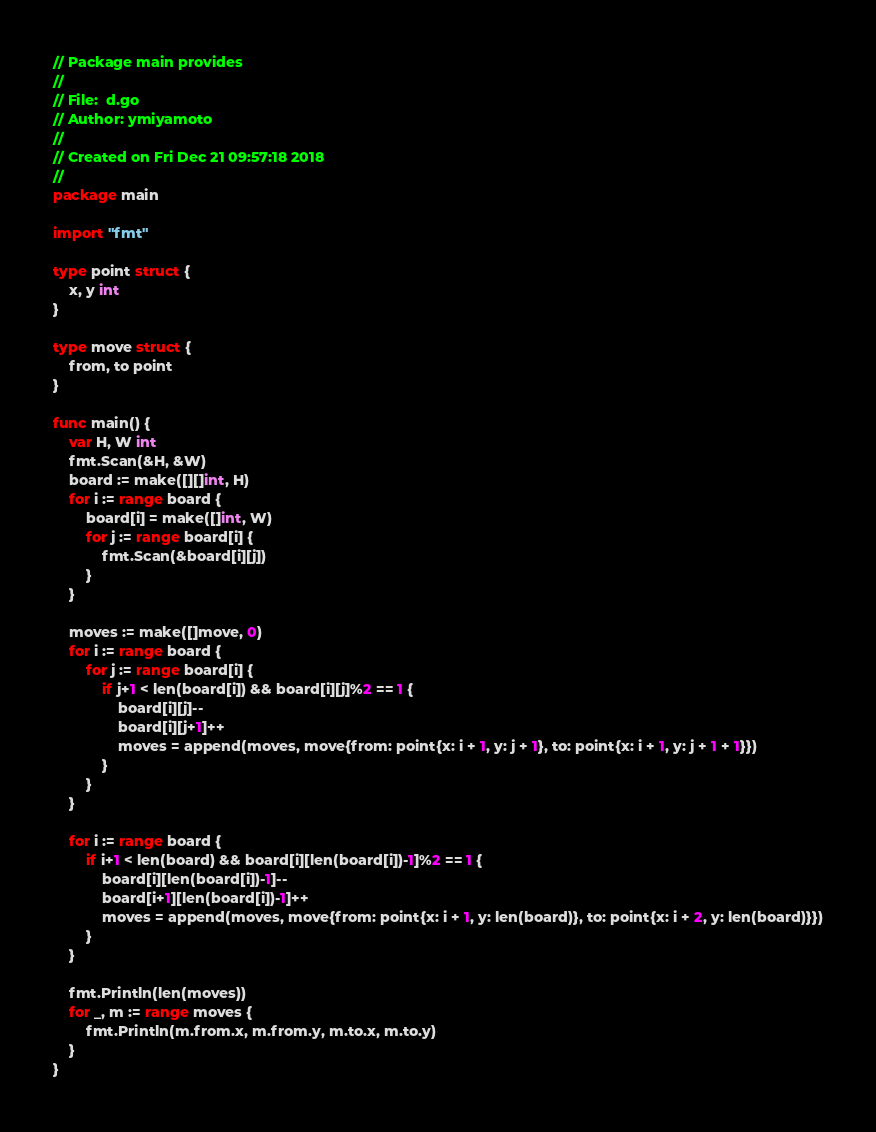<code> <loc_0><loc_0><loc_500><loc_500><_Go_>// Package main provides
//
// File:  d.go
// Author: ymiyamoto
//
// Created on Fri Dec 21 09:57:18 2018
//
package main

import "fmt"

type point struct {
	x, y int
}

type move struct {
	from, to point
}

func main() {
	var H, W int
	fmt.Scan(&H, &W)
	board := make([][]int, H)
	for i := range board {
		board[i] = make([]int, W)
		for j := range board[i] {
			fmt.Scan(&board[i][j])
		}
	}

	moves := make([]move, 0)
	for i := range board {
		for j := range board[i] {
			if j+1 < len(board[i]) && board[i][j]%2 == 1 {
				board[i][j]--
				board[i][j+1]++
				moves = append(moves, move{from: point{x: i + 1, y: j + 1}, to: point{x: i + 1, y: j + 1 + 1}})
			}
		}
	}

	for i := range board {
		if i+1 < len(board) && board[i][len(board[i])-1]%2 == 1 {
			board[i][len(board[i])-1]--
			board[i+1][len(board[i])-1]++
			moves = append(moves, move{from: point{x: i + 1, y: len(board)}, to: point{x: i + 2, y: len(board)}})
		}
	}

	fmt.Println(len(moves))
	for _, m := range moves {
		fmt.Println(m.from.x, m.from.y, m.to.x, m.to.y)
	}
}
</code> 